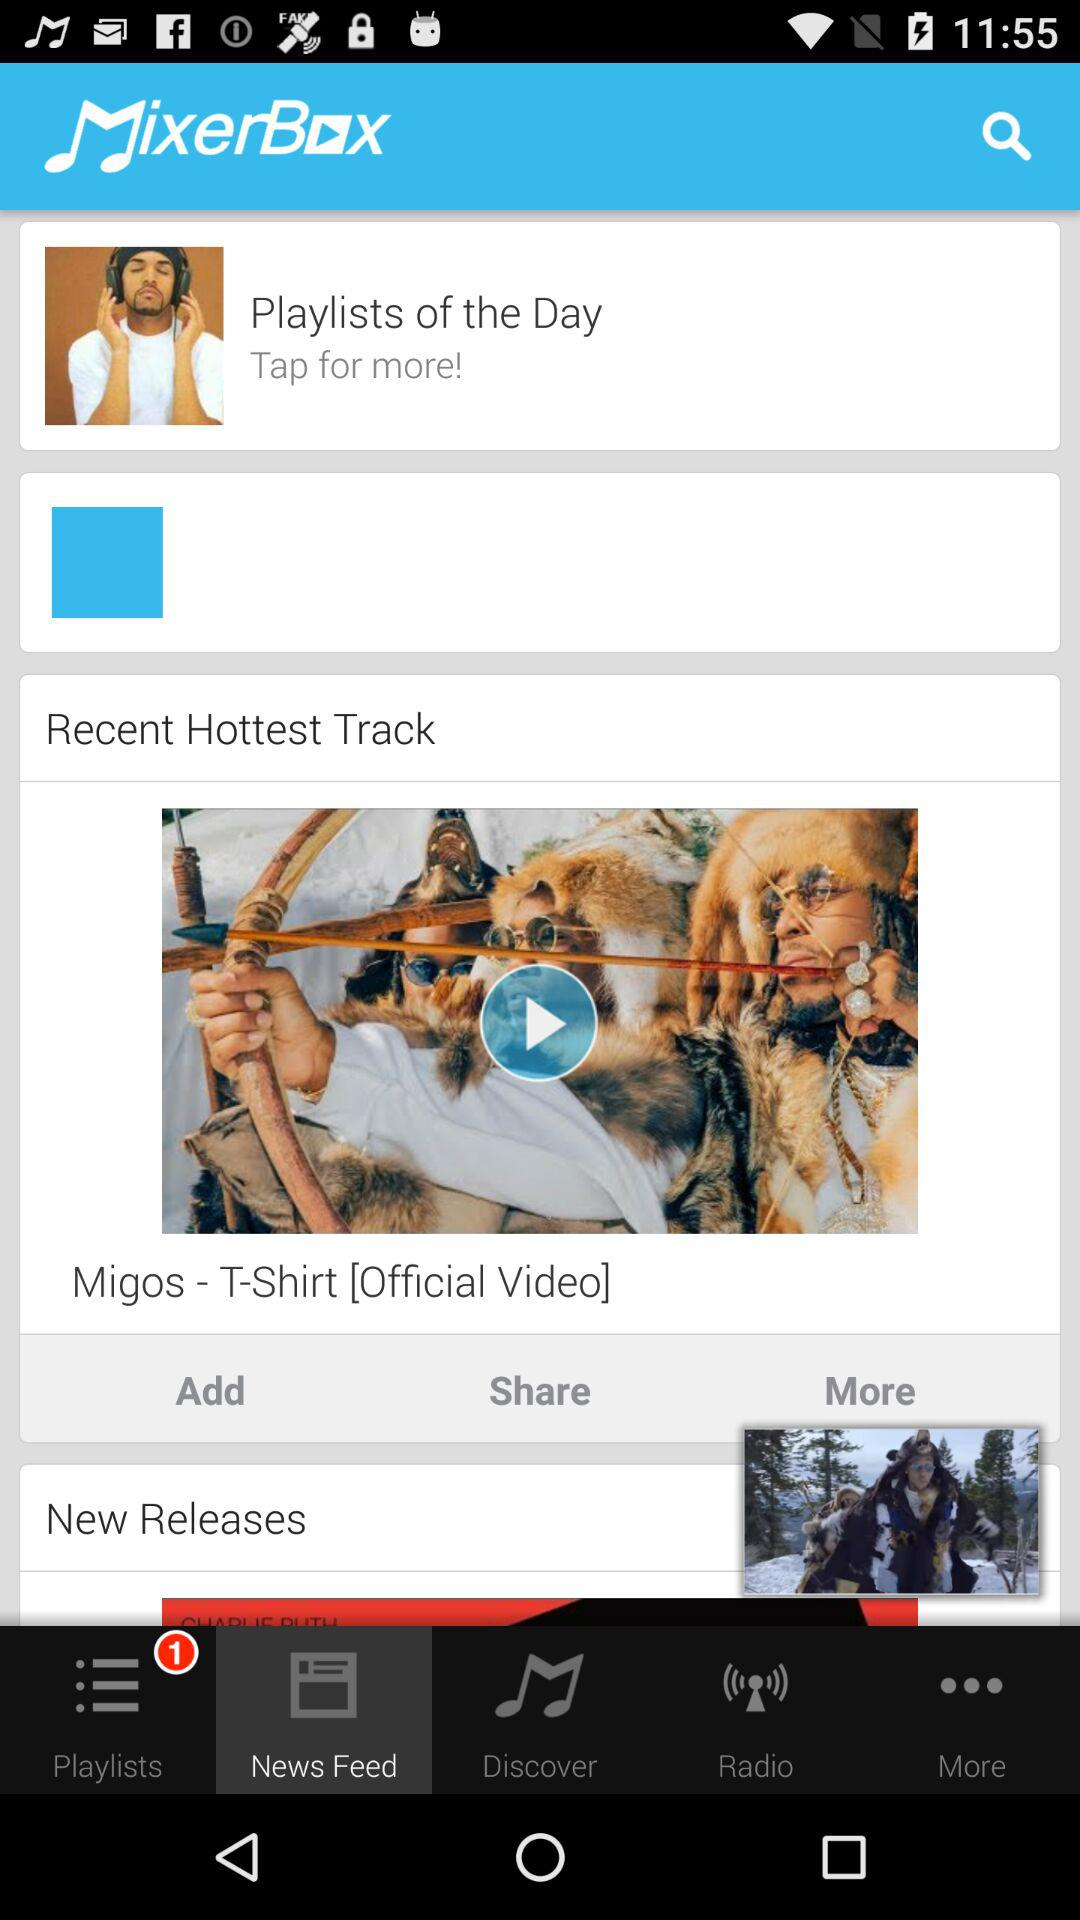What is the count of playlists? The count of playlists is 1. 